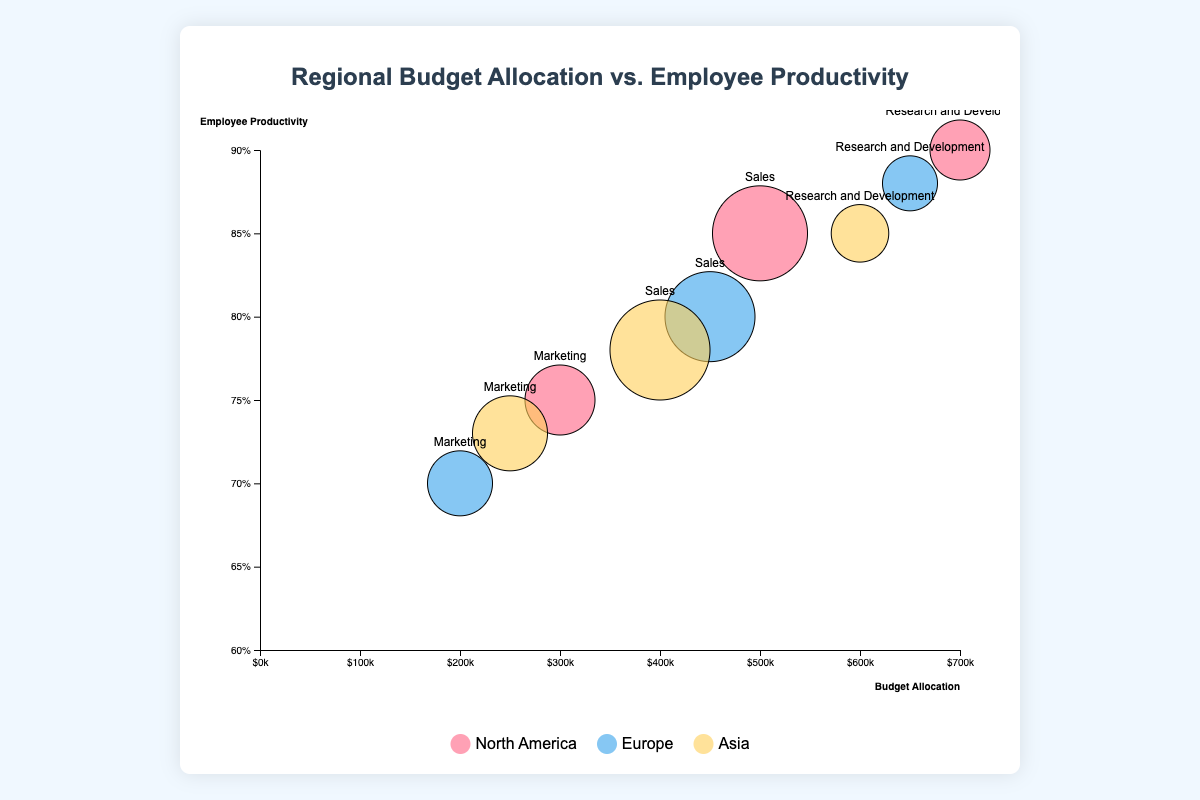What is the title of the bubble chart? The title is generally prominently displayed at the top of the chart. By examining the top of the bubble chart, you can see the text "Regional Budget Allocation vs. Employee Productivity" clearly indicated as the title.
Answer: Regional Budget Allocation vs. Employee Productivity How is the y-axis labeled? The y-axis label is typically placed along the vertical axis to describe what the y-axis data represents. In this chart, the label on the vertical axis reads "Employee Productivity."
Answer: Employee Productivity Which region has the highest budget allocation in the Research and Development department? By examining the largest values on the x-axis for the Research and Development department across regions, the highest budget allocation can be identified. The North America region has the highest budget allocation of $700,000 for Research and Development, as positioned the furthest on the right on the x-axis.
Answer: North America Which department has the highest employee productivity in Europe? To find this, you need to look at points representing European departments along the vertical axis and note which extends the furthest upward. The Research and Development department in Europe has the highest employee productivity at 88%.
Answer: Research and Development How many total employees are there in the Marketing departments across all regions? To find the total number of employees in the Marketing department, sum the number of employees in Marketing across North America, Europe, and Asia. The numbers are 100 (North America), 90 (Europe), and 110 (Asia). Summing these gives 100 + 90 + 110 = 300.
Answer: 300 Which region has the lowest productivity in the Marketing department? Examine the points representing the Marketing department in each region and identify the one lowest on the y-axis. Europe shows the lowest productivity in the Marketing department at 70%.
Answer: Europe Between North America and Asia, which region has a higher average productivity in the Sales department? Calculate the average productivity for Sales departments in North America and Asia. North America has an employee productivity of 85%, and Asia has 78%. The average for each region is, therefore, 85% for North America and 78% for Asia.
Answer: North America Which bubble represents the department with the most employees, and which region does it belong to? The size of the bubbles correlates with the number of employees. The largest bubble represents the Sales department in Asia with 160 employees.
Answer: Sales department in Asia What is the relationship between budget allocation and employee productivity in the North America department of Research and Development? Determine the relationship by examining the position of the North America Research and Development bubble. Its high budget allocation of $700,000 corresponds with high employee productivity at 90%. This suggests a positive relationship.
Answer: Positive relationship Compare the total budget allocation for the Sales departments across all regions. Sum the budget allocation for Sales departments in North America, Europe, and Asia. The values are $500,000 (North America), $450,000 (Europe), and $400,000 (Asia). Summing these gives $500,000 + $450,000 + $400,000 = $1,350,000.
Answer: $1,350,000 